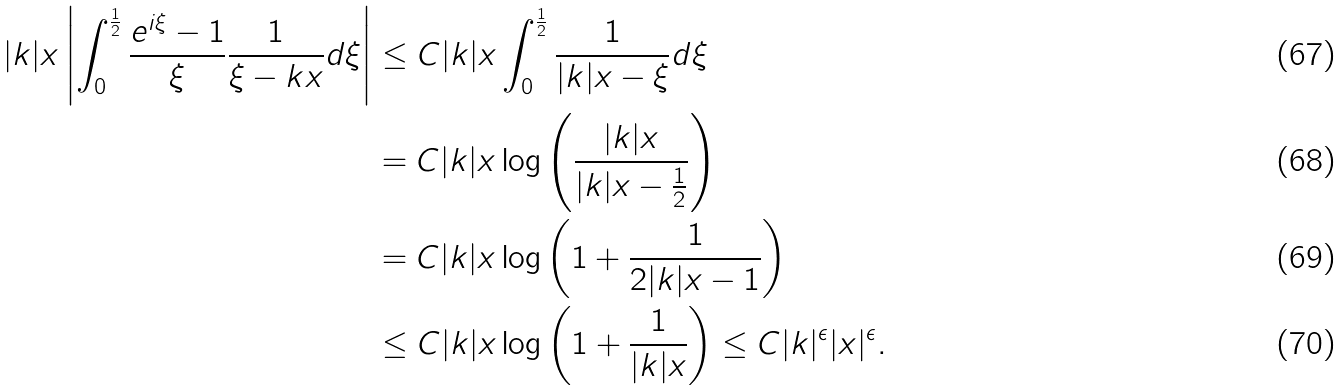<formula> <loc_0><loc_0><loc_500><loc_500>| k | x \left | \int _ { 0 } ^ { \frac { 1 } { 2 } } \frac { e ^ { i \xi } - 1 } { \xi } \frac { 1 } { \xi - k x } d \xi \right | & \leq C | k | x \int _ { 0 } ^ { \frac { 1 } { 2 } } \frac { 1 } { | k | x - \xi } d \xi \\ & = C | k | x \log \left ( \frac { | k | x } { | k | x - \frac { 1 } { 2 } } \right ) \\ & = C | k | x \log \left ( 1 + \frac { 1 } { 2 | k | x - 1 } \right ) \\ & \leq C | k | x \log \left ( 1 + \frac { 1 } { | k | x } \right ) \leq C | k | ^ { \epsilon } | x | ^ { \epsilon } .</formula> 